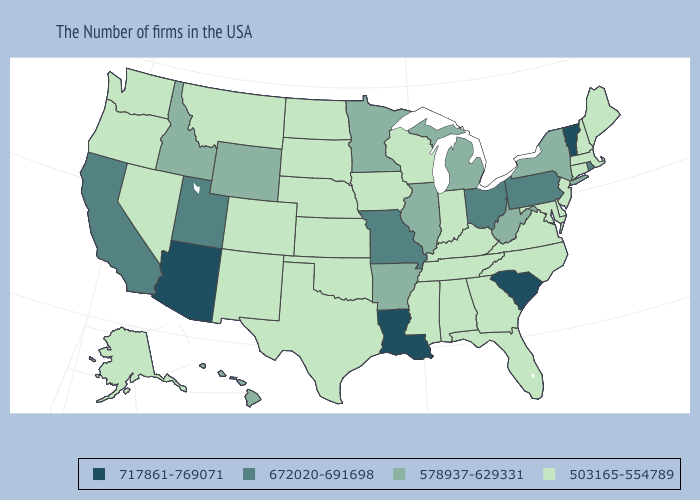What is the value of Nebraska?
Quick response, please. 503165-554789. What is the value of Hawaii?
Be succinct. 578937-629331. Which states have the highest value in the USA?
Give a very brief answer. Vermont, South Carolina, Louisiana, Arizona. Among the states that border New Mexico , does Utah have the highest value?
Keep it brief. No. What is the value of Mississippi?
Answer briefly. 503165-554789. Name the states that have a value in the range 717861-769071?
Be succinct. Vermont, South Carolina, Louisiana, Arizona. What is the value of California?
Keep it brief. 672020-691698. Is the legend a continuous bar?
Short answer required. No. What is the value of Hawaii?
Answer briefly. 578937-629331. Does Ohio have a higher value than Louisiana?
Answer briefly. No. Name the states that have a value in the range 672020-691698?
Write a very short answer. Rhode Island, Pennsylvania, Ohio, Missouri, Utah, California. Does the first symbol in the legend represent the smallest category?
Be succinct. No. Does Arizona have the highest value in the West?
Concise answer only. Yes. Does Arkansas have the lowest value in the USA?
Give a very brief answer. No. 